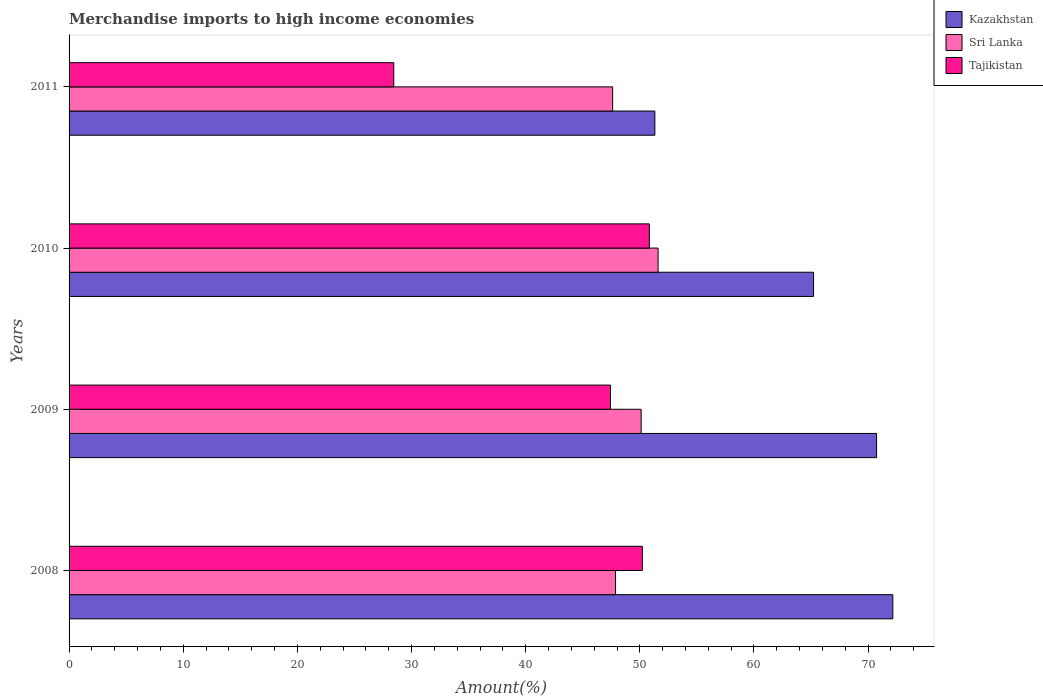How many different coloured bars are there?
Provide a short and direct response. 3. How many groups of bars are there?
Make the answer very short. 4. Are the number of bars per tick equal to the number of legend labels?
Provide a short and direct response. Yes. Are the number of bars on each tick of the Y-axis equal?
Keep it short and to the point. Yes. What is the label of the 2nd group of bars from the top?
Your answer should be compact. 2010. In how many cases, is the number of bars for a given year not equal to the number of legend labels?
Keep it short and to the point. 0. What is the percentage of amount earned from merchandise imports in Sri Lanka in 2011?
Make the answer very short. 47.62. Across all years, what is the maximum percentage of amount earned from merchandise imports in Tajikistan?
Offer a terse response. 50.83. Across all years, what is the minimum percentage of amount earned from merchandise imports in Tajikistan?
Give a very brief answer. 28.45. In which year was the percentage of amount earned from merchandise imports in Tajikistan maximum?
Your answer should be compact. 2010. In which year was the percentage of amount earned from merchandise imports in Sri Lanka minimum?
Offer a very short reply. 2011. What is the total percentage of amount earned from merchandise imports in Kazakhstan in the graph?
Offer a terse response. 259.44. What is the difference between the percentage of amount earned from merchandise imports in Tajikistan in 2009 and that in 2010?
Your answer should be compact. -3.4. What is the difference between the percentage of amount earned from merchandise imports in Tajikistan in 2011 and the percentage of amount earned from merchandise imports in Kazakhstan in 2008?
Your answer should be very brief. -43.72. What is the average percentage of amount earned from merchandise imports in Tajikistan per year?
Your answer should be very brief. 44.23. In the year 2009, what is the difference between the percentage of amount earned from merchandise imports in Tajikistan and percentage of amount earned from merchandise imports in Sri Lanka?
Provide a succinct answer. -2.69. What is the ratio of the percentage of amount earned from merchandise imports in Tajikistan in 2010 to that in 2011?
Your response must be concise. 1.79. Is the difference between the percentage of amount earned from merchandise imports in Tajikistan in 2008 and 2010 greater than the difference between the percentage of amount earned from merchandise imports in Sri Lanka in 2008 and 2010?
Your answer should be compact. Yes. What is the difference between the highest and the second highest percentage of amount earned from merchandise imports in Sri Lanka?
Make the answer very short. 1.48. What is the difference between the highest and the lowest percentage of amount earned from merchandise imports in Sri Lanka?
Offer a terse response. 3.98. Is the sum of the percentage of amount earned from merchandise imports in Kazakhstan in 2009 and 2010 greater than the maximum percentage of amount earned from merchandise imports in Tajikistan across all years?
Provide a short and direct response. Yes. What does the 2nd bar from the top in 2009 represents?
Your response must be concise. Sri Lanka. What does the 1st bar from the bottom in 2010 represents?
Your answer should be very brief. Kazakhstan. Is it the case that in every year, the sum of the percentage of amount earned from merchandise imports in Sri Lanka and percentage of amount earned from merchandise imports in Tajikistan is greater than the percentage of amount earned from merchandise imports in Kazakhstan?
Offer a very short reply. Yes. How many bars are there?
Make the answer very short. 12. Are the values on the major ticks of X-axis written in scientific E-notation?
Provide a succinct answer. No. Does the graph contain any zero values?
Your answer should be very brief. No. What is the title of the graph?
Provide a short and direct response. Merchandise imports to high income economies. What is the label or title of the X-axis?
Provide a succinct answer. Amount(%). What is the Amount(%) in Kazakhstan in 2008?
Give a very brief answer. 72.16. What is the Amount(%) in Sri Lanka in 2008?
Provide a succinct answer. 47.87. What is the Amount(%) of Tajikistan in 2008?
Make the answer very short. 50.22. What is the Amount(%) of Kazakhstan in 2009?
Your answer should be very brief. 70.74. What is the Amount(%) in Sri Lanka in 2009?
Your answer should be compact. 50.12. What is the Amount(%) in Tajikistan in 2009?
Provide a short and direct response. 47.43. What is the Amount(%) of Kazakhstan in 2010?
Offer a very short reply. 65.22. What is the Amount(%) of Sri Lanka in 2010?
Your answer should be compact. 51.6. What is the Amount(%) of Tajikistan in 2010?
Ensure brevity in your answer.  50.83. What is the Amount(%) in Kazakhstan in 2011?
Keep it short and to the point. 51.32. What is the Amount(%) in Sri Lanka in 2011?
Your response must be concise. 47.62. What is the Amount(%) of Tajikistan in 2011?
Offer a very short reply. 28.45. Across all years, what is the maximum Amount(%) of Kazakhstan?
Give a very brief answer. 72.16. Across all years, what is the maximum Amount(%) of Sri Lanka?
Your answer should be compact. 51.6. Across all years, what is the maximum Amount(%) of Tajikistan?
Keep it short and to the point. 50.83. Across all years, what is the minimum Amount(%) of Kazakhstan?
Provide a succinct answer. 51.32. Across all years, what is the minimum Amount(%) in Sri Lanka?
Keep it short and to the point. 47.62. Across all years, what is the minimum Amount(%) of Tajikistan?
Make the answer very short. 28.45. What is the total Amount(%) in Kazakhstan in the graph?
Provide a succinct answer. 259.44. What is the total Amount(%) of Sri Lanka in the graph?
Ensure brevity in your answer.  197.21. What is the total Amount(%) of Tajikistan in the graph?
Make the answer very short. 176.93. What is the difference between the Amount(%) of Kazakhstan in 2008 and that in 2009?
Keep it short and to the point. 1.42. What is the difference between the Amount(%) in Sri Lanka in 2008 and that in 2009?
Offer a terse response. -2.24. What is the difference between the Amount(%) in Tajikistan in 2008 and that in 2009?
Your answer should be very brief. 2.79. What is the difference between the Amount(%) of Kazakhstan in 2008 and that in 2010?
Your response must be concise. 6.94. What is the difference between the Amount(%) in Sri Lanka in 2008 and that in 2010?
Make the answer very short. -3.73. What is the difference between the Amount(%) of Tajikistan in 2008 and that in 2010?
Offer a terse response. -0.61. What is the difference between the Amount(%) of Kazakhstan in 2008 and that in 2011?
Provide a short and direct response. 20.85. What is the difference between the Amount(%) in Sri Lanka in 2008 and that in 2011?
Provide a succinct answer. 0.25. What is the difference between the Amount(%) in Tajikistan in 2008 and that in 2011?
Offer a terse response. 21.77. What is the difference between the Amount(%) of Kazakhstan in 2009 and that in 2010?
Ensure brevity in your answer.  5.52. What is the difference between the Amount(%) of Sri Lanka in 2009 and that in 2010?
Offer a very short reply. -1.48. What is the difference between the Amount(%) in Tajikistan in 2009 and that in 2010?
Give a very brief answer. -3.4. What is the difference between the Amount(%) in Kazakhstan in 2009 and that in 2011?
Provide a short and direct response. 19.42. What is the difference between the Amount(%) in Sri Lanka in 2009 and that in 2011?
Make the answer very short. 2.5. What is the difference between the Amount(%) in Tajikistan in 2009 and that in 2011?
Provide a short and direct response. 18.98. What is the difference between the Amount(%) in Kazakhstan in 2010 and that in 2011?
Make the answer very short. 13.9. What is the difference between the Amount(%) in Sri Lanka in 2010 and that in 2011?
Make the answer very short. 3.98. What is the difference between the Amount(%) in Tajikistan in 2010 and that in 2011?
Ensure brevity in your answer.  22.39. What is the difference between the Amount(%) of Kazakhstan in 2008 and the Amount(%) of Sri Lanka in 2009?
Offer a terse response. 22.05. What is the difference between the Amount(%) of Kazakhstan in 2008 and the Amount(%) of Tajikistan in 2009?
Offer a terse response. 24.73. What is the difference between the Amount(%) in Sri Lanka in 2008 and the Amount(%) in Tajikistan in 2009?
Keep it short and to the point. 0.44. What is the difference between the Amount(%) in Kazakhstan in 2008 and the Amount(%) in Sri Lanka in 2010?
Your response must be concise. 20.56. What is the difference between the Amount(%) of Kazakhstan in 2008 and the Amount(%) of Tajikistan in 2010?
Offer a terse response. 21.33. What is the difference between the Amount(%) of Sri Lanka in 2008 and the Amount(%) of Tajikistan in 2010?
Give a very brief answer. -2.96. What is the difference between the Amount(%) of Kazakhstan in 2008 and the Amount(%) of Sri Lanka in 2011?
Ensure brevity in your answer.  24.55. What is the difference between the Amount(%) of Kazakhstan in 2008 and the Amount(%) of Tajikistan in 2011?
Keep it short and to the point. 43.72. What is the difference between the Amount(%) in Sri Lanka in 2008 and the Amount(%) in Tajikistan in 2011?
Offer a terse response. 19.43. What is the difference between the Amount(%) of Kazakhstan in 2009 and the Amount(%) of Sri Lanka in 2010?
Your response must be concise. 19.14. What is the difference between the Amount(%) of Kazakhstan in 2009 and the Amount(%) of Tajikistan in 2010?
Ensure brevity in your answer.  19.91. What is the difference between the Amount(%) in Sri Lanka in 2009 and the Amount(%) in Tajikistan in 2010?
Your answer should be very brief. -0.72. What is the difference between the Amount(%) in Kazakhstan in 2009 and the Amount(%) in Sri Lanka in 2011?
Provide a succinct answer. 23.12. What is the difference between the Amount(%) of Kazakhstan in 2009 and the Amount(%) of Tajikistan in 2011?
Your answer should be very brief. 42.29. What is the difference between the Amount(%) of Sri Lanka in 2009 and the Amount(%) of Tajikistan in 2011?
Offer a very short reply. 21.67. What is the difference between the Amount(%) in Kazakhstan in 2010 and the Amount(%) in Sri Lanka in 2011?
Offer a very short reply. 17.6. What is the difference between the Amount(%) of Kazakhstan in 2010 and the Amount(%) of Tajikistan in 2011?
Offer a very short reply. 36.77. What is the difference between the Amount(%) of Sri Lanka in 2010 and the Amount(%) of Tajikistan in 2011?
Provide a succinct answer. 23.15. What is the average Amount(%) of Kazakhstan per year?
Provide a short and direct response. 64.86. What is the average Amount(%) of Sri Lanka per year?
Your answer should be very brief. 49.3. What is the average Amount(%) of Tajikistan per year?
Make the answer very short. 44.23. In the year 2008, what is the difference between the Amount(%) in Kazakhstan and Amount(%) in Sri Lanka?
Provide a short and direct response. 24.29. In the year 2008, what is the difference between the Amount(%) in Kazakhstan and Amount(%) in Tajikistan?
Give a very brief answer. 21.94. In the year 2008, what is the difference between the Amount(%) of Sri Lanka and Amount(%) of Tajikistan?
Your response must be concise. -2.35. In the year 2009, what is the difference between the Amount(%) in Kazakhstan and Amount(%) in Sri Lanka?
Ensure brevity in your answer.  20.62. In the year 2009, what is the difference between the Amount(%) in Kazakhstan and Amount(%) in Tajikistan?
Keep it short and to the point. 23.31. In the year 2009, what is the difference between the Amount(%) of Sri Lanka and Amount(%) of Tajikistan?
Provide a succinct answer. 2.69. In the year 2010, what is the difference between the Amount(%) in Kazakhstan and Amount(%) in Sri Lanka?
Offer a terse response. 13.62. In the year 2010, what is the difference between the Amount(%) of Kazakhstan and Amount(%) of Tajikistan?
Provide a succinct answer. 14.39. In the year 2010, what is the difference between the Amount(%) in Sri Lanka and Amount(%) in Tajikistan?
Ensure brevity in your answer.  0.77. In the year 2011, what is the difference between the Amount(%) of Kazakhstan and Amount(%) of Sri Lanka?
Provide a succinct answer. 3.7. In the year 2011, what is the difference between the Amount(%) in Kazakhstan and Amount(%) in Tajikistan?
Your answer should be compact. 22.87. In the year 2011, what is the difference between the Amount(%) of Sri Lanka and Amount(%) of Tajikistan?
Offer a very short reply. 19.17. What is the ratio of the Amount(%) in Kazakhstan in 2008 to that in 2009?
Offer a very short reply. 1.02. What is the ratio of the Amount(%) of Sri Lanka in 2008 to that in 2009?
Keep it short and to the point. 0.96. What is the ratio of the Amount(%) in Tajikistan in 2008 to that in 2009?
Your answer should be very brief. 1.06. What is the ratio of the Amount(%) of Kazakhstan in 2008 to that in 2010?
Keep it short and to the point. 1.11. What is the ratio of the Amount(%) in Sri Lanka in 2008 to that in 2010?
Your answer should be compact. 0.93. What is the ratio of the Amount(%) of Tajikistan in 2008 to that in 2010?
Your response must be concise. 0.99. What is the ratio of the Amount(%) of Kazakhstan in 2008 to that in 2011?
Your response must be concise. 1.41. What is the ratio of the Amount(%) in Sri Lanka in 2008 to that in 2011?
Ensure brevity in your answer.  1.01. What is the ratio of the Amount(%) of Tajikistan in 2008 to that in 2011?
Your response must be concise. 1.77. What is the ratio of the Amount(%) of Kazakhstan in 2009 to that in 2010?
Provide a short and direct response. 1.08. What is the ratio of the Amount(%) in Sri Lanka in 2009 to that in 2010?
Keep it short and to the point. 0.97. What is the ratio of the Amount(%) in Tajikistan in 2009 to that in 2010?
Provide a succinct answer. 0.93. What is the ratio of the Amount(%) of Kazakhstan in 2009 to that in 2011?
Ensure brevity in your answer.  1.38. What is the ratio of the Amount(%) in Sri Lanka in 2009 to that in 2011?
Provide a short and direct response. 1.05. What is the ratio of the Amount(%) of Tajikistan in 2009 to that in 2011?
Ensure brevity in your answer.  1.67. What is the ratio of the Amount(%) of Kazakhstan in 2010 to that in 2011?
Your answer should be very brief. 1.27. What is the ratio of the Amount(%) in Sri Lanka in 2010 to that in 2011?
Make the answer very short. 1.08. What is the ratio of the Amount(%) in Tajikistan in 2010 to that in 2011?
Give a very brief answer. 1.79. What is the difference between the highest and the second highest Amount(%) of Kazakhstan?
Offer a terse response. 1.42. What is the difference between the highest and the second highest Amount(%) in Sri Lanka?
Your answer should be compact. 1.48. What is the difference between the highest and the second highest Amount(%) in Tajikistan?
Your response must be concise. 0.61. What is the difference between the highest and the lowest Amount(%) in Kazakhstan?
Offer a terse response. 20.85. What is the difference between the highest and the lowest Amount(%) in Sri Lanka?
Provide a short and direct response. 3.98. What is the difference between the highest and the lowest Amount(%) in Tajikistan?
Give a very brief answer. 22.39. 